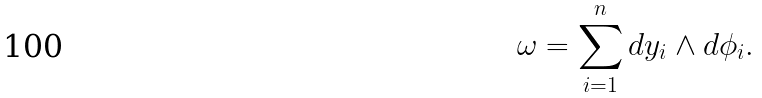Convert formula to latex. <formula><loc_0><loc_0><loc_500><loc_500>\omega = \sum _ { i = 1 } ^ { n } d y _ { i } \wedge d \phi _ { i } .</formula> 